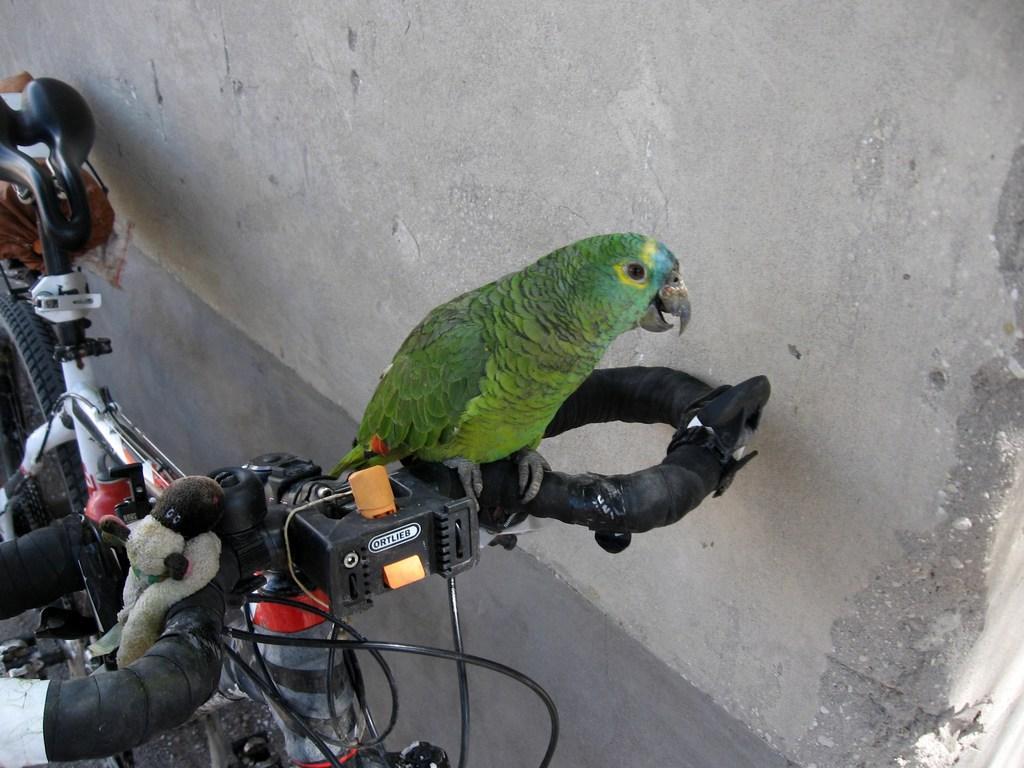Could you give a brief overview of what you see in this image? In the picture we can see a bicycle and parrot sitting on the handle of the bicycle and the parrot is green in color and the bicycle is near the wall. 